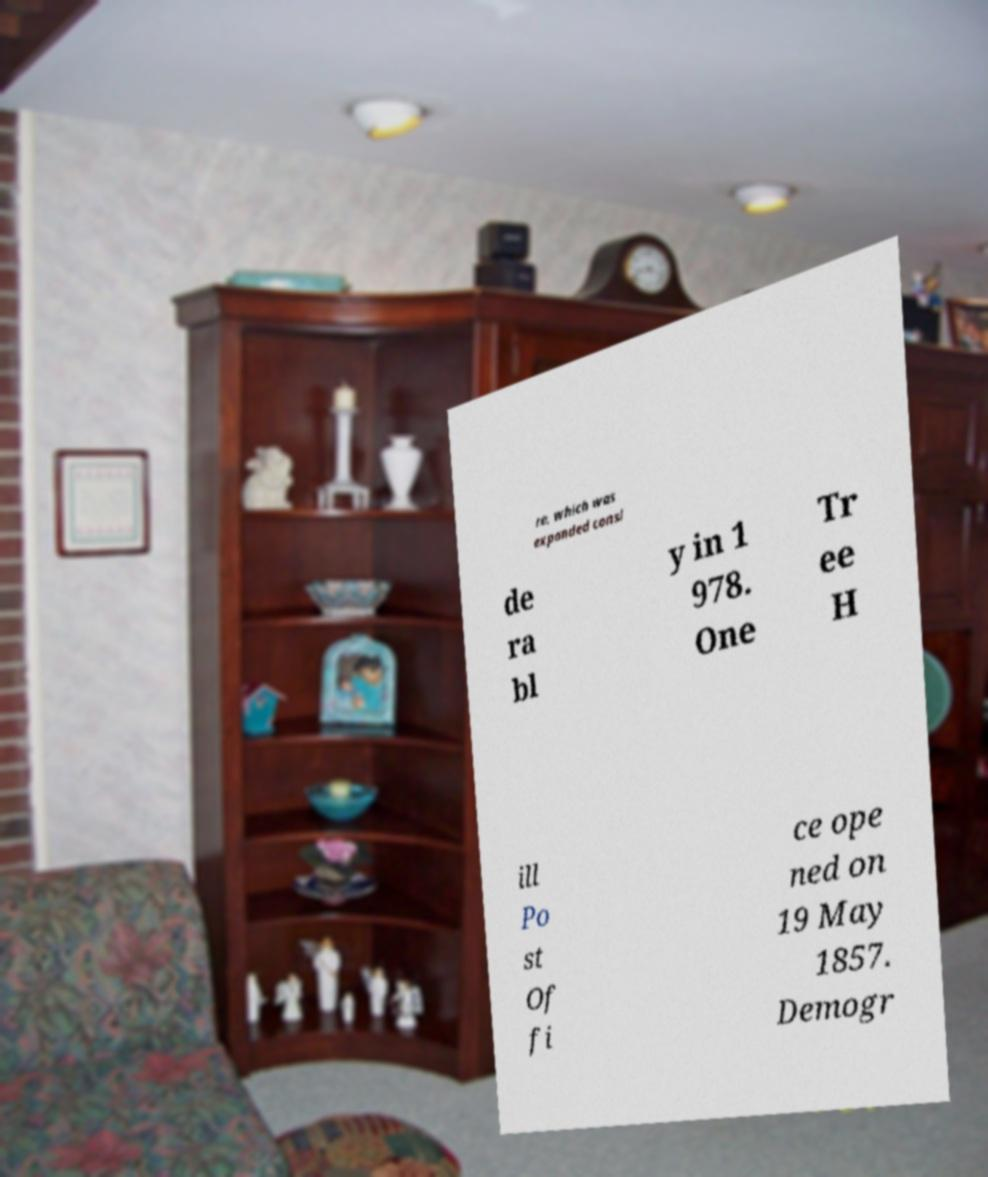What messages or text are displayed in this image? I need them in a readable, typed format. re, which was expanded consi de ra bl y in 1 978. One Tr ee H ill Po st Of fi ce ope ned on 19 May 1857. Demogr 